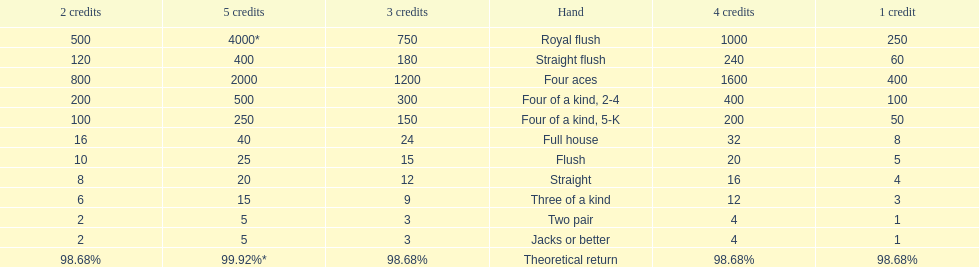How many credits do you have to spend to get at least 2000 in payout if you had four aces? 5 credits. Give me the full table as a dictionary. {'header': ['2 credits', '5 credits', '3 credits', 'Hand', '4 credits', '1 credit'], 'rows': [['500', '4000*', '750', 'Royal flush', '1000', '250'], ['120', '400', '180', 'Straight flush', '240', '60'], ['800', '2000', '1200', 'Four aces', '1600', '400'], ['200', '500', '300', 'Four of a kind, 2-4', '400', '100'], ['100', '250', '150', 'Four of a kind, 5-K', '200', '50'], ['16', '40', '24', 'Full house', '32', '8'], ['10', '25', '15', 'Flush', '20', '5'], ['8', '20', '12', 'Straight', '16', '4'], ['6', '15', '9', 'Three of a kind', '12', '3'], ['2', '5', '3', 'Two pair', '4', '1'], ['2', '5', '3', 'Jacks or better', '4', '1'], ['98.68%', '99.92%*', '98.68%', 'Theoretical return', '98.68%', '98.68%']]} 